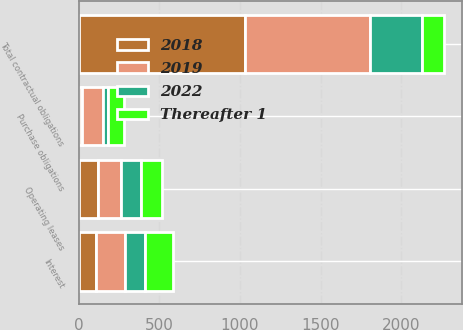Convert chart to OTSL. <chart><loc_0><loc_0><loc_500><loc_500><stacked_bar_chart><ecel><fcel>Interest<fcel>Operating leases<fcel>Purchase obligations<fcel>Total contractual obligations<nl><fcel>2019<fcel>175<fcel>141<fcel>128<fcel>775<nl><fcel>Thereafter 1<fcel>175<fcel>132<fcel>101<fcel>136.5<nl><fcel>2022<fcel>125<fcel>126<fcel>29<fcel>319<nl><fcel>2018<fcel>109<fcel>118<fcel>22<fcel>1033<nl></chart> 